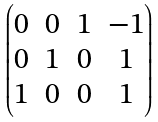<formula> <loc_0><loc_0><loc_500><loc_500>\begin{pmatrix} 0 & 0 & 1 & - 1 \\ 0 & 1 & 0 & 1 \\ 1 & 0 & 0 & 1 \end{pmatrix}</formula> 